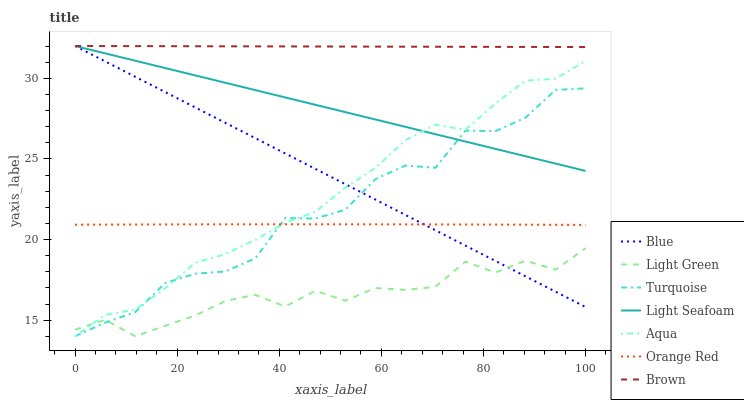Does Light Green have the minimum area under the curve?
Answer yes or no. Yes. Does Brown have the maximum area under the curve?
Answer yes or no. Yes. Does Turquoise have the minimum area under the curve?
Answer yes or no. No. Does Turquoise have the maximum area under the curve?
Answer yes or no. No. Is Brown the smoothest?
Answer yes or no. Yes. Is Turquoise the roughest?
Answer yes or no. Yes. Is Turquoise the smoothest?
Answer yes or no. No. Is Brown the roughest?
Answer yes or no. No. Does Turquoise have the lowest value?
Answer yes or no. Yes. Does Brown have the lowest value?
Answer yes or no. No. Does Light Seafoam have the highest value?
Answer yes or no. Yes. Does Turquoise have the highest value?
Answer yes or no. No. Is Light Green less than Brown?
Answer yes or no. Yes. Is Brown greater than Light Green?
Answer yes or no. Yes. Does Turquoise intersect Blue?
Answer yes or no. Yes. Is Turquoise less than Blue?
Answer yes or no. No. Is Turquoise greater than Blue?
Answer yes or no. No. Does Light Green intersect Brown?
Answer yes or no. No. 